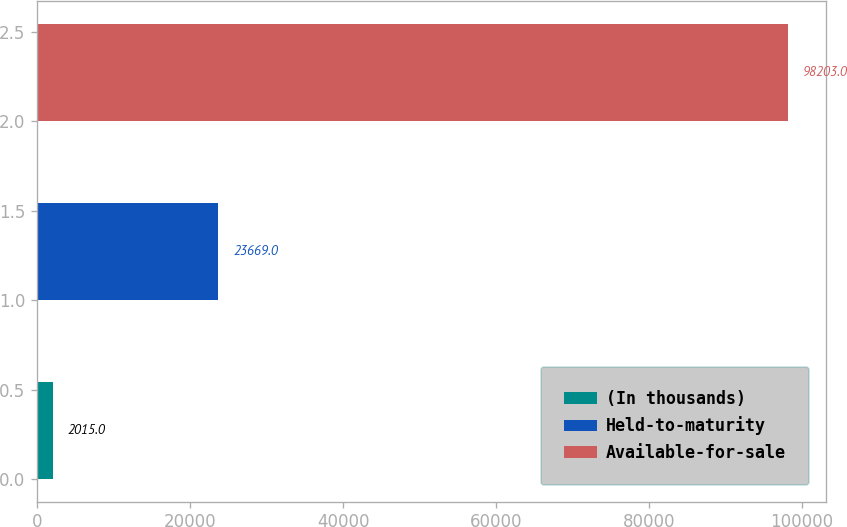Convert chart to OTSL. <chart><loc_0><loc_0><loc_500><loc_500><bar_chart><fcel>(In thousands)<fcel>Held-to-maturity<fcel>Available-for-sale<nl><fcel>2015<fcel>23669<fcel>98203<nl></chart> 